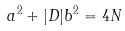<formula> <loc_0><loc_0><loc_500><loc_500>a ^ { 2 } + | D | b ^ { 2 } = 4 N</formula> 